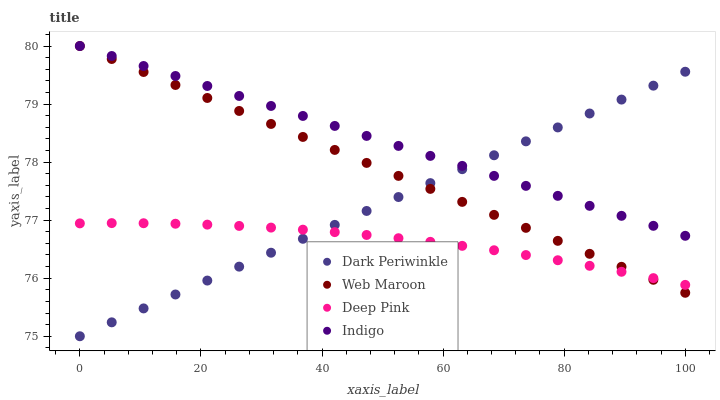Does Deep Pink have the minimum area under the curve?
Answer yes or no. Yes. Does Indigo have the maximum area under the curve?
Answer yes or no. Yes. Does Web Maroon have the minimum area under the curve?
Answer yes or no. No. Does Web Maroon have the maximum area under the curve?
Answer yes or no. No. Is Web Maroon the smoothest?
Answer yes or no. Yes. Is Deep Pink the roughest?
Answer yes or no. Yes. Is Deep Pink the smoothest?
Answer yes or no. No. Is Web Maroon the roughest?
Answer yes or no. No. Does Dark Periwinkle have the lowest value?
Answer yes or no. Yes. Does Deep Pink have the lowest value?
Answer yes or no. No. Does Web Maroon have the highest value?
Answer yes or no. Yes. Does Deep Pink have the highest value?
Answer yes or no. No. Is Deep Pink less than Indigo?
Answer yes or no. Yes. Is Indigo greater than Deep Pink?
Answer yes or no. Yes. Does Deep Pink intersect Dark Periwinkle?
Answer yes or no. Yes. Is Deep Pink less than Dark Periwinkle?
Answer yes or no. No. Is Deep Pink greater than Dark Periwinkle?
Answer yes or no. No. Does Deep Pink intersect Indigo?
Answer yes or no. No. 